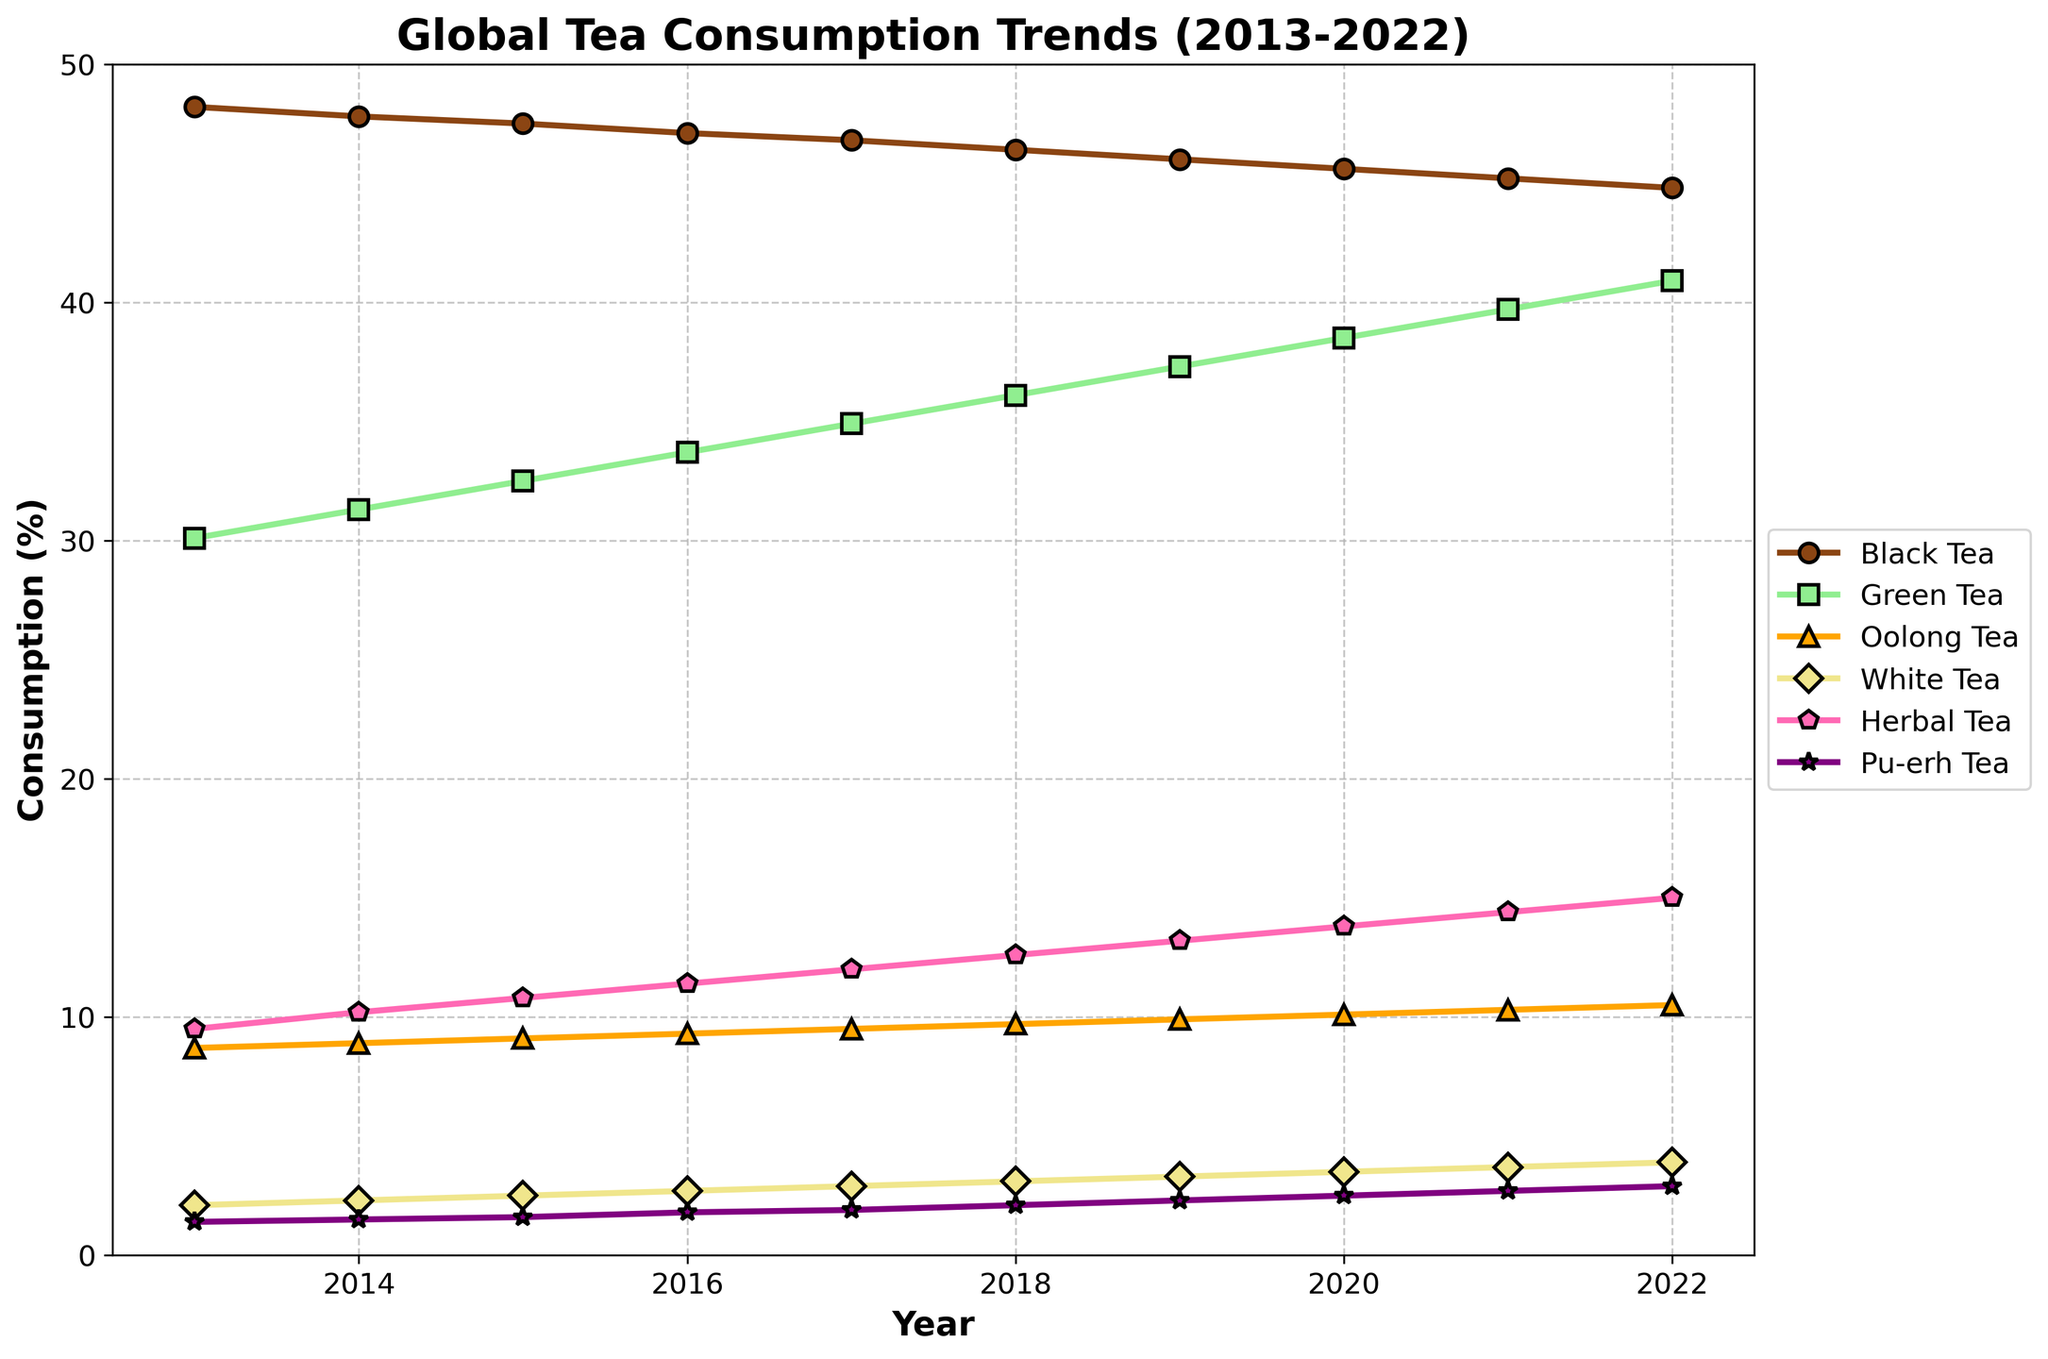Which type of tea showed the highest increase in consumption from 2013 to 2022? To determine the tea type with the highest increase, subtract the 2013 consumption percentage from the 2022 percentage for each tea type. Black Tea increased by (44.8 - 48.2 = -3.4), Green Tea by (40.9 - 30.1 = 10.8), Oolong Tea by (10.5 - 8.7 = 1.8), White Tea by (3.9 - 2.1 = 1.8), Herbal Tea by (15.0 - 9.5 = 5.5), and Pu-erh Tea by (2.9 - 1.4 = 1.5). The highest increase is in Green Tea (10.8).
Answer: Green Tea What was the consumption trend of Black Tea over the decade? Look at the line for Black Tea to observe its trend. The Black Tea line shows a slight decline from 48.2% to 44.8% from 2013 to 2022.
Answer: Decline In 2018, which types of tea had a consumption rate above 10%? Check the values for each tea type in 2018. Black Tea (46.4%), Green Tea (36.1%), and Herbal Tea (12.6%) each had consumption rates above 10%.
Answer: Black Tea, Green Tea, Herbal Tea How much did Herbal Tea consumption change from 2013 to 2022, and how does that compare to the change in Oolong Tea consumption? Calculate the change for both types of tea by subtracting the 2013 values from the 2022 values: Herbal Tea (15.0 - 9.5 = 5.5) and Oolong Tea (10.5 - 8.7 = 1.8). Compare the changes to identify that Herbal Tea increased by 5.5, while Oolong Tea increased by 1.8.
Answer: Herbal Tea increased more, by 5.5 In which year did Green Tea's consumption surpass 35%? Look at the Green Tea line in the chart and trace it over the years until it surpasses 35%. The line crosses the 35% mark in 2017.
Answer: 2017 Which type of tea had the least variation in consumption over the decade? Assess the vertical distance variation of each tea type’s line from 2013 to 2022. Pu-erh Tea had the least variation, going from 1.4% to 2.9%.
Answer: Pu-erh Tea By how much did Pu-erh Tea consumption increase on average per year from 2013 to 2022? Find the total increase over the decade (2.9 - 1.4 = 1.5) and divide it by the number of years (2022 - 2013 = 9 years). The average annual increase is 1.5 / 9 ≈ 0.167 per year.
Answer: 0.167% In which year did White Tea consumption reach or exceed 3%? Check the trend line for White Tea until it reaches or exceeds the 3% consumption mark. This occurred in 2019.
Answer: 2019 